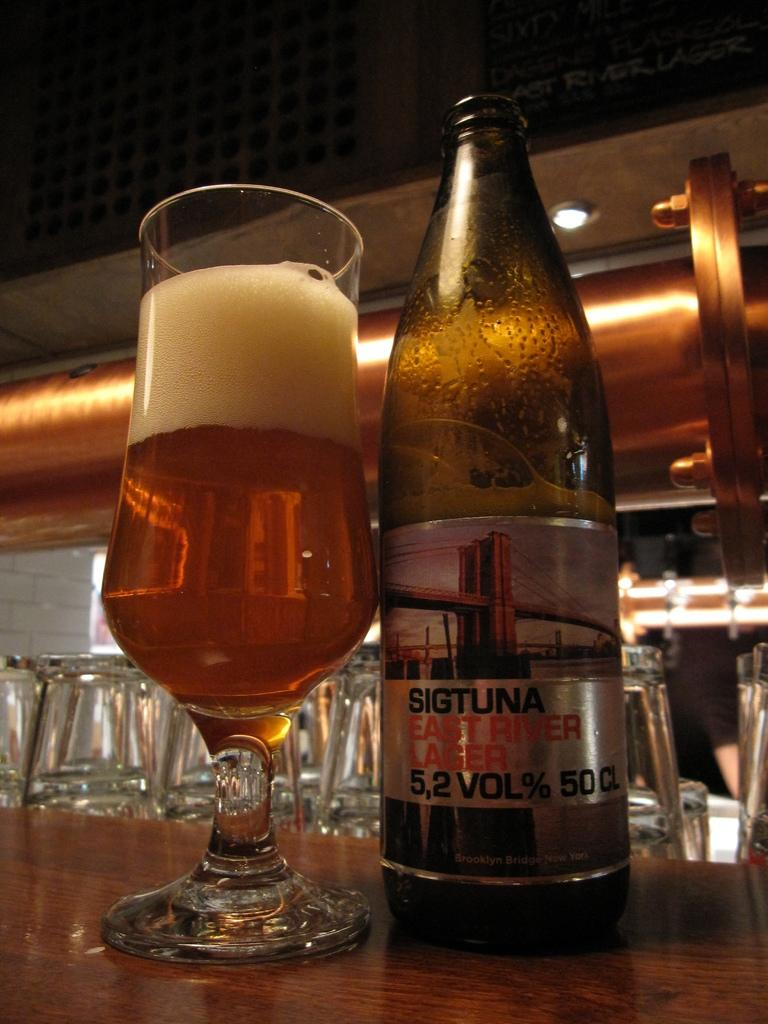<image>
Describe the image concisely. A Sigtuna branded beer is poured into a glass. 